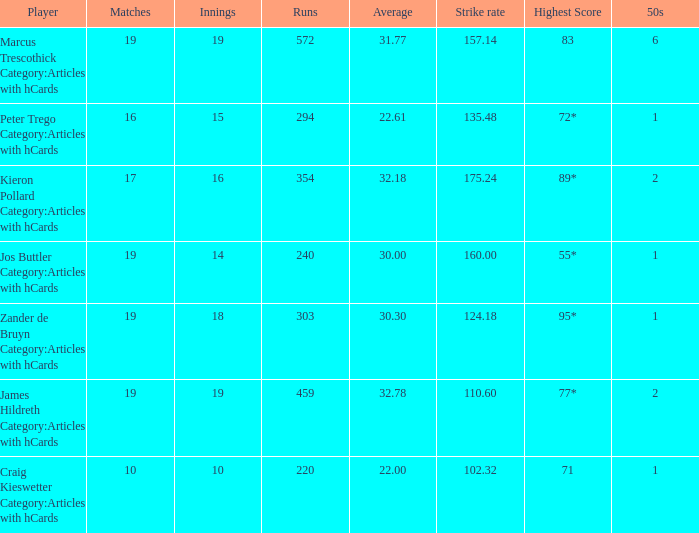78? 110.6. 